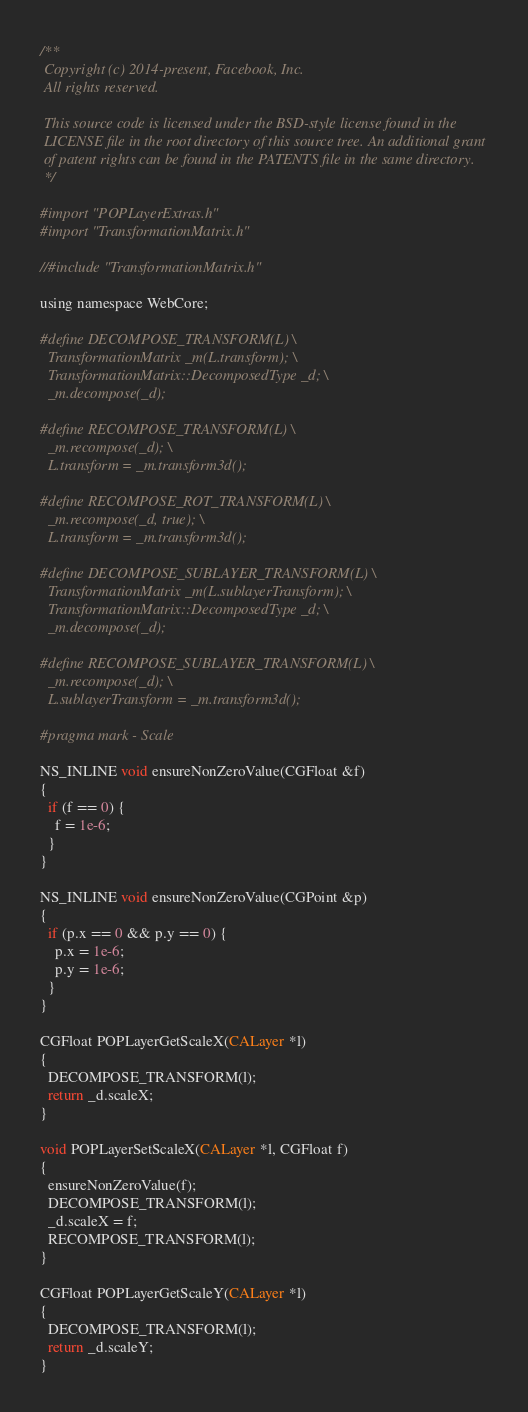Convert code to text. <code><loc_0><loc_0><loc_500><loc_500><_ObjectiveC_>/**
 Copyright (c) 2014-present, Facebook, Inc.
 All rights reserved.
 
 This source code is licensed under the BSD-style license found in the
 LICENSE file in the root directory of this source tree. An additional grant
 of patent rights can be found in the PATENTS file in the same directory.
 */

#import "POPLayerExtras.h"
#import "TransformationMatrix.h"

//#include "TransformationMatrix.h"

using namespace WebCore;

#define DECOMPOSE_TRANSFORM(L) \
  TransformationMatrix _m(L.transform); \
  TransformationMatrix::DecomposedType _d; \
  _m.decompose(_d);

#define RECOMPOSE_TRANSFORM(L) \
  _m.recompose(_d); \
  L.transform = _m.transform3d();

#define RECOMPOSE_ROT_TRANSFORM(L) \
  _m.recompose(_d, true); \
  L.transform = _m.transform3d();

#define DECOMPOSE_SUBLAYER_TRANSFORM(L) \
  TransformationMatrix _m(L.sublayerTransform); \
  TransformationMatrix::DecomposedType _d; \
  _m.decompose(_d);

#define RECOMPOSE_SUBLAYER_TRANSFORM(L) \
  _m.recompose(_d); \
  L.sublayerTransform = _m.transform3d();

#pragma mark - Scale

NS_INLINE void ensureNonZeroValue(CGFloat &f)
{
  if (f == 0) {
    f = 1e-6;
  }
}

NS_INLINE void ensureNonZeroValue(CGPoint &p)
{
  if (p.x == 0 && p.y == 0) {
    p.x = 1e-6;
    p.y = 1e-6;
  }
}

CGFloat POPLayerGetScaleX(CALayer *l)
{
  DECOMPOSE_TRANSFORM(l);
  return _d.scaleX;
}

void POPLayerSetScaleX(CALayer *l, CGFloat f)
{
  ensureNonZeroValue(f);
  DECOMPOSE_TRANSFORM(l);
  _d.scaleX = f;
  RECOMPOSE_TRANSFORM(l);
}

CGFloat POPLayerGetScaleY(CALayer *l)
{
  DECOMPOSE_TRANSFORM(l);
  return _d.scaleY;
}
</code> 